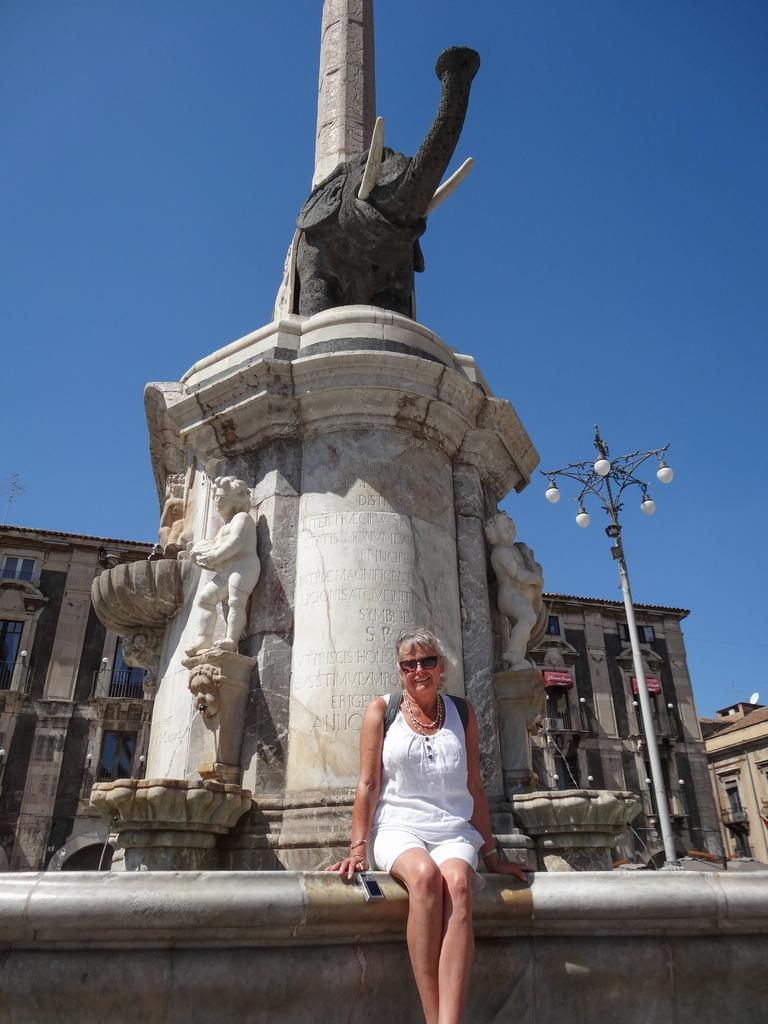What is the main subject in the center of the image? There is a sculpture in the center of the image. Are there any people in the image? Yes, there is a lady sitting in the center of the image. What type of arithmetic problem is the lady solving in the image? There is no indication in the image that the lady is solving an arithmetic problem. 